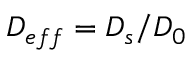Convert formula to latex. <formula><loc_0><loc_0><loc_500><loc_500>D _ { e f f } = D _ { s } / D _ { 0 }</formula> 